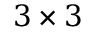Convert formula to latex. <formula><loc_0><loc_0><loc_500><loc_500>3 \times 3</formula> 